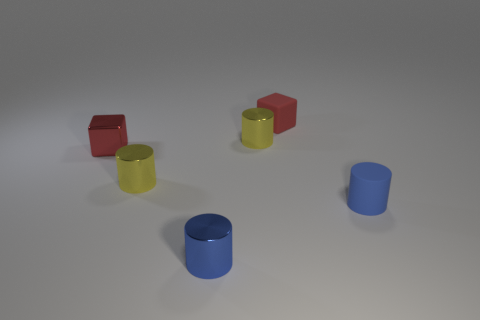Subtract 1 cylinders. How many cylinders are left? 3 Add 4 red metal objects. How many objects exist? 10 Subtract all cylinders. How many objects are left? 2 Subtract 2 yellow cylinders. How many objects are left? 4 Subtract all tiny shiny cubes. Subtract all tiny red rubber blocks. How many objects are left? 4 Add 4 small blue rubber things. How many small blue rubber things are left? 5 Add 4 large metallic balls. How many large metallic balls exist? 4 